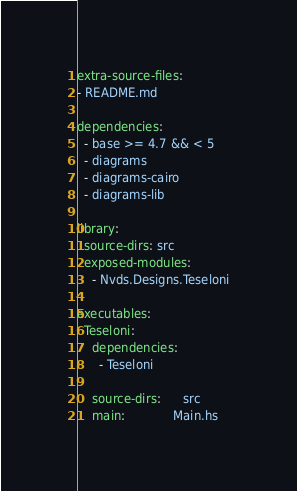<code> <loc_0><loc_0><loc_500><loc_500><_YAML_>extra-source-files:
- README.md

dependencies:
  - base >= 4.7 && < 5
  - diagrams
  - diagrams-cairo
  - diagrams-lib

library:
  source-dirs: src
  exposed-modules:
    - Nvds.Designs.Teseloni

executables:
  Teseloni:
    dependencies:
      - Teseloni

    source-dirs:      src
    main:             Main.hs
</code> 